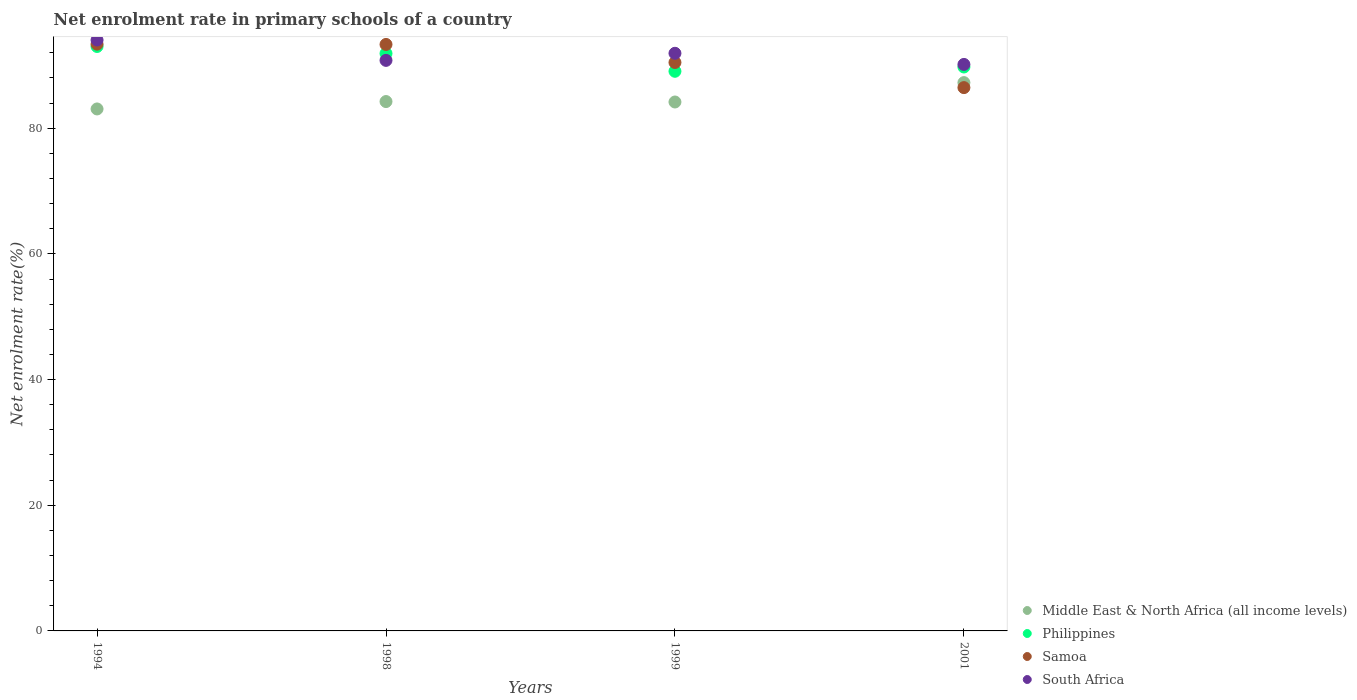How many different coloured dotlines are there?
Ensure brevity in your answer.  4. What is the net enrolment rate in primary schools in South Africa in 1994?
Make the answer very short. 94.03. Across all years, what is the maximum net enrolment rate in primary schools in South Africa?
Provide a short and direct response. 94.03. Across all years, what is the minimum net enrolment rate in primary schools in South Africa?
Make the answer very short. 90.15. In which year was the net enrolment rate in primary schools in Philippines maximum?
Ensure brevity in your answer.  1994. In which year was the net enrolment rate in primary schools in Middle East & North Africa (all income levels) minimum?
Ensure brevity in your answer.  1994. What is the total net enrolment rate in primary schools in Samoa in the graph?
Provide a short and direct response. 363.62. What is the difference between the net enrolment rate in primary schools in Middle East & North Africa (all income levels) in 1994 and that in 1998?
Provide a short and direct response. -1.18. What is the difference between the net enrolment rate in primary schools in Philippines in 1998 and the net enrolment rate in primary schools in Middle East & North Africa (all income levels) in 1994?
Ensure brevity in your answer.  8.83. What is the average net enrolment rate in primary schools in Philippines per year?
Offer a terse response. 90.92. In the year 1999, what is the difference between the net enrolment rate in primary schools in Philippines and net enrolment rate in primary schools in Samoa?
Ensure brevity in your answer.  -1.4. What is the ratio of the net enrolment rate in primary schools in Philippines in 1999 to that in 2001?
Ensure brevity in your answer.  0.99. Is the difference between the net enrolment rate in primary schools in Philippines in 1999 and 2001 greater than the difference between the net enrolment rate in primary schools in Samoa in 1999 and 2001?
Make the answer very short. No. What is the difference between the highest and the second highest net enrolment rate in primary schools in South Africa?
Keep it short and to the point. 2.11. What is the difference between the highest and the lowest net enrolment rate in primary schools in Samoa?
Your answer should be compact. 6.91. In how many years, is the net enrolment rate in primary schools in South Africa greater than the average net enrolment rate in primary schools in South Africa taken over all years?
Give a very brief answer. 2. Is the sum of the net enrolment rate in primary schools in Philippines in 1998 and 2001 greater than the maximum net enrolment rate in primary schools in Middle East & North Africa (all income levels) across all years?
Provide a short and direct response. Yes. Is it the case that in every year, the sum of the net enrolment rate in primary schools in South Africa and net enrolment rate in primary schools in Samoa  is greater than the net enrolment rate in primary schools in Philippines?
Your answer should be compact. Yes. Is the net enrolment rate in primary schools in Philippines strictly greater than the net enrolment rate in primary schools in South Africa over the years?
Your response must be concise. No. Is the net enrolment rate in primary schools in Philippines strictly less than the net enrolment rate in primary schools in Samoa over the years?
Offer a very short reply. No. How many dotlines are there?
Your response must be concise. 4. How many years are there in the graph?
Offer a very short reply. 4. What is the difference between two consecutive major ticks on the Y-axis?
Your answer should be very brief. 20. Does the graph contain grids?
Offer a very short reply. No. How many legend labels are there?
Make the answer very short. 4. How are the legend labels stacked?
Provide a succinct answer. Vertical. What is the title of the graph?
Provide a succinct answer. Net enrolment rate in primary schools of a country. What is the label or title of the X-axis?
Give a very brief answer. Years. What is the label or title of the Y-axis?
Provide a succinct answer. Net enrolment rate(%). What is the Net enrolment rate(%) of Middle East & North Africa (all income levels) in 1994?
Your answer should be compact. 83.06. What is the Net enrolment rate(%) in Philippines in 1994?
Provide a succinct answer. 93.01. What is the Net enrolment rate(%) of Samoa in 1994?
Ensure brevity in your answer.  93.37. What is the Net enrolment rate(%) in South Africa in 1994?
Offer a very short reply. 94.03. What is the Net enrolment rate(%) of Middle East & North Africa (all income levels) in 1998?
Make the answer very short. 84.24. What is the Net enrolment rate(%) in Philippines in 1998?
Your answer should be very brief. 91.89. What is the Net enrolment rate(%) in Samoa in 1998?
Keep it short and to the point. 93.33. What is the Net enrolment rate(%) in South Africa in 1998?
Ensure brevity in your answer.  90.79. What is the Net enrolment rate(%) of Middle East & North Africa (all income levels) in 1999?
Ensure brevity in your answer.  84.17. What is the Net enrolment rate(%) of Philippines in 1999?
Ensure brevity in your answer.  89.06. What is the Net enrolment rate(%) of Samoa in 1999?
Provide a succinct answer. 90.46. What is the Net enrolment rate(%) in South Africa in 1999?
Keep it short and to the point. 91.92. What is the Net enrolment rate(%) in Middle East & North Africa (all income levels) in 2001?
Keep it short and to the point. 87.25. What is the Net enrolment rate(%) in Philippines in 2001?
Offer a terse response. 89.74. What is the Net enrolment rate(%) in Samoa in 2001?
Give a very brief answer. 86.46. What is the Net enrolment rate(%) of South Africa in 2001?
Your response must be concise. 90.15. Across all years, what is the maximum Net enrolment rate(%) in Middle East & North Africa (all income levels)?
Your answer should be very brief. 87.25. Across all years, what is the maximum Net enrolment rate(%) in Philippines?
Keep it short and to the point. 93.01. Across all years, what is the maximum Net enrolment rate(%) of Samoa?
Your answer should be very brief. 93.37. Across all years, what is the maximum Net enrolment rate(%) in South Africa?
Ensure brevity in your answer.  94.03. Across all years, what is the minimum Net enrolment rate(%) in Middle East & North Africa (all income levels)?
Keep it short and to the point. 83.06. Across all years, what is the minimum Net enrolment rate(%) in Philippines?
Keep it short and to the point. 89.06. Across all years, what is the minimum Net enrolment rate(%) of Samoa?
Give a very brief answer. 86.46. Across all years, what is the minimum Net enrolment rate(%) of South Africa?
Give a very brief answer. 90.15. What is the total Net enrolment rate(%) of Middle East & North Africa (all income levels) in the graph?
Your response must be concise. 338.73. What is the total Net enrolment rate(%) of Philippines in the graph?
Your answer should be very brief. 363.7. What is the total Net enrolment rate(%) in Samoa in the graph?
Your response must be concise. 363.62. What is the total Net enrolment rate(%) of South Africa in the graph?
Offer a very short reply. 366.9. What is the difference between the Net enrolment rate(%) in Middle East & North Africa (all income levels) in 1994 and that in 1998?
Keep it short and to the point. -1.18. What is the difference between the Net enrolment rate(%) of Philippines in 1994 and that in 1998?
Provide a succinct answer. 1.12. What is the difference between the Net enrolment rate(%) in Samoa in 1994 and that in 1998?
Your answer should be very brief. 0.04. What is the difference between the Net enrolment rate(%) of South Africa in 1994 and that in 1998?
Make the answer very short. 3.24. What is the difference between the Net enrolment rate(%) of Middle East & North Africa (all income levels) in 1994 and that in 1999?
Ensure brevity in your answer.  -1.11. What is the difference between the Net enrolment rate(%) of Philippines in 1994 and that in 1999?
Keep it short and to the point. 3.95. What is the difference between the Net enrolment rate(%) in Samoa in 1994 and that in 1999?
Give a very brief answer. 2.92. What is the difference between the Net enrolment rate(%) of South Africa in 1994 and that in 1999?
Your answer should be very brief. 2.11. What is the difference between the Net enrolment rate(%) in Middle East & North Africa (all income levels) in 1994 and that in 2001?
Offer a very short reply. -4.19. What is the difference between the Net enrolment rate(%) of Philippines in 1994 and that in 2001?
Offer a very short reply. 3.27. What is the difference between the Net enrolment rate(%) in Samoa in 1994 and that in 2001?
Make the answer very short. 6.91. What is the difference between the Net enrolment rate(%) of South Africa in 1994 and that in 2001?
Give a very brief answer. 3.88. What is the difference between the Net enrolment rate(%) in Middle East & North Africa (all income levels) in 1998 and that in 1999?
Keep it short and to the point. 0.07. What is the difference between the Net enrolment rate(%) of Philippines in 1998 and that in 1999?
Offer a very short reply. 2.83. What is the difference between the Net enrolment rate(%) of Samoa in 1998 and that in 1999?
Provide a succinct answer. 2.87. What is the difference between the Net enrolment rate(%) in South Africa in 1998 and that in 1999?
Offer a very short reply. -1.13. What is the difference between the Net enrolment rate(%) in Middle East & North Africa (all income levels) in 1998 and that in 2001?
Your answer should be compact. -3.01. What is the difference between the Net enrolment rate(%) of Philippines in 1998 and that in 2001?
Your answer should be compact. 2.15. What is the difference between the Net enrolment rate(%) in Samoa in 1998 and that in 2001?
Your response must be concise. 6.87. What is the difference between the Net enrolment rate(%) of South Africa in 1998 and that in 2001?
Keep it short and to the point. 0.64. What is the difference between the Net enrolment rate(%) in Middle East & North Africa (all income levels) in 1999 and that in 2001?
Ensure brevity in your answer.  -3.08. What is the difference between the Net enrolment rate(%) in Philippines in 1999 and that in 2001?
Provide a short and direct response. -0.68. What is the difference between the Net enrolment rate(%) of Samoa in 1999 and that in 2001?
Provide a succinct answer. 4. What is the difference between the Net enrolment rate(%) of South Africa in 1999 and that in 2001?
Provide a succinct answer. 1.77. What is the difference between the Net enrolment rate(%) of Middle East & North Africa (all income levels) in 1994 and the Net enrolment rate(%) of Philippines in 1998?
Offer a terse response. -8.83. What is the difference between the Net enrolment rate(%) in Middle East & North Africa (all income levels) in 1994 and the Net enrolment rate(%) in Samoa in 1998?
Your response must be concise. -10.27. What is the difference between the Net enrolment rate(%) in Middle East & North Africa (all income levels) in 1994 and the Net enrolment rate(%) in South Africa in 1998?
Keep it short and to the point. -7.73. What is the difference between the Net enrolment rate(%) of Philippines in 1994 and the Net enrolment rate(%) of Samoa in 1998?
Your answer should be compact. -0.32. What is the difference between the Net enrolment rate(%) of Philippines in 1994 and the Net enrolment rate(%) of South Africa in 1998?
Your answer should be very brief. 2.21. What is the difference between the Net enrolment rate(%) of Samoa in 1994 and the Net enrolment rate(%) of South Africa in 1998?
Your answer should be compact. 2.58. What is the difference between the Net enrolment rate(%) in Middle East & North Africa (all income levels) in 1994 and the Net enrolment rate(%) in Philippines in 1999?
Give a very brief answer. -5.99. What is the difference between the Net enrolment rate(%) of Middle East & North Africa (all income levels) in 1994 and the Net enrolment rate(%) of Samoa in 1999?
Give a very brief answer. -7.39. What is the difference between the Net enrolment rate(%) of Middle East & North Africa (all income levels) in 1994 and the Net enrolment rate(%) of South Africa in 1999?
Offer a very short reply. -8.86. What is the difference between the Net enrolment rate(%) of Philippines in 1994 and the Net enrolment rate(%) of Samoa in 1999?
Your response must be concise. 2.55. What is the difference between the Net enrolment rate(%) of Philippines in 1994 and the Net enrolment rate(%) of South Africa in 1999?
Provide a succinct answer. 1.09. What is the difference between the Net enrolment rate(%) of Samoa in 1994 and the Net enrolment rate(%) of South Africa in 1999?
Your response must be concise. 1.45. What is the difference between the Net enrolment rate(%) of Middle East & North Africa (all income levels) in 1994 and the Net enrolment rate(%) of Philippines in 2001?
Offer a very short reply. -6.68. What is the difference between the Net enrolment rate(%) in Middle East & North Africa (all income levels) in 1994 and the Net enrolment rate(%) in Samoa in 2001?
Offer a very short reply. -3.4. What is the difference between the Net enrolment rate(%) in Middle East & North Africa (all income levels) in 1994 and the Net enrolment rate(%) in South Africa in 2001?
Ensure brevity in your answer.  -7.09. What is the difference between the Net enrolment rate(%) in Philippines in 1994 and the Net enrolment rate(%) in Samoa in 2001?
Ensure brevity in your answer.  6.55. What is the difference between the Net enrolment rate(%) in Philippines in 1994 and the Net enrolment rate(%) in South Africa in 2001?
Your answer should be very brief. 2.86. What is the difference between the Net enrolment rate(%) in Samoa in 1994 and the Net enrolment rate(%) in South Africa in 2001?
Offer a terse response. 3.22. What is the difference between the Net enrolment rate(%) of Middle East & North Africa (all income levels) in 1998 and the Net enrolment rate(%) of Philippines in 1999?
Ensure brevity in your answer.  -4.82. What is the difference between the Net enrolment rate(%) in Middle East & North Africa (all income levels) in 1998 and the Net enrolment rate(%) in Samoa in 1999?
Ensure brevity in your answer.  -6.22. What is the difference between the Net enrolment rate(%) in Middle East & North Africa (all income levels) in 1998 and the Net enrolment rate(%) in South Africa in 1999?
Give a very brief answer. -7.68. What is the difference between the Net enrolment rate(%) of Philippines in 1998 and the Net enrolment rate(%) of Samoa in 1999?
Provide a succinct answer. 1.43. What is the difference between the Net enrolment rate(%) of Philippines in 1998 and the Net enrolment rate(%) of South Africa in 1999?
Offer a very short reply. -0.03. What is the difference between the Net enrolment rate(%) in Samoa in 1998 and the Net enrolment rate(%) in South Africa in 1999?
Keep it short and to the point. 1.41. What is the difference between the Net enrolment rate(%) in Middle East & North Africa (all income levels) in 1998 and the Net enrolment rate(%) in Samoa in 2001?
Make the answer very short. -2.22. What is the difference between the Net enrolment rate(%) in Middle East & North Africa (all income levels) in 1998 and the Net enrolment rate(%) in South Africa in 2001?
Offer a terse response. -5.91. What is the difference between the Net enrolment rate(%) of Philippines in 1998 and the Net enrolment rate(%) of Samoa in 2001?
Keep it short and to the point. 5.43. What is the difference between the Net enrolment rate(%) of Philippines in 1998 and the Net enrolment rate(%) of South Africa in 2001?
Your answer should be very brief. 1.74. What is the difference between the Net enrolment rate(%) of Samoa in 1998 and the Net enrolment rate(%) of South Africa in 2001?
Give a very brief answer. 3.18. What is the difference between the Net enrolment rate(%) of Middle East & North Africa (all income levels) in 1999 and the Net enrolment rate(%) of Philippines in 2001?
Keep it short and to the point. -5.57. What is the difference between the Net enrolment rate(%) of Middle East & North Africa (all income levels) in 1999 and the Net enrolment rate(%) of Samoa in 2001?
Provide a short and direct response. -2.29. What is the difference between the Net enrolment rate(%) of Middle East & North Africa (all income levels) in 1999 and the Net enrolment rate(%) of South Africa in 2001?
Your response must be concise. -5.98. What is the difference between the Net enrolment rate(%) of Philippines in 1999 and the Net enrolment rate(%) of Samoa in 2001?
Give a very brief answer. 2.6. What is the difference between the Net enrolment rate(%) of Philippines in 1999 and the Net enrolment rate(%) of South Africa in 2001?
Your answer should be very brief. -1.09. What is the difference between the Net enrolment rate(%) of Samoa in 1999 and the Net enrolment rate(%) of South Africa in 2001?
Provide a succinct answer. 0.31. What is the average Net enrolment rate(%) in Middle East & North Africa (all income levels) per year?
Offer a terse response. 84.68. What is the average Net enrolment rate(%) of Philippines per year?
Keep it short and to the point. 90.92. What is the average Net enrolment rate(%) in Samoa per year?
Provide a short and direct response. 90.9. What is the average Net enrolment rate(%) of South Africa per year?
Your response must be concise. 91.72. In the year 1994, what is the difference between the Net enrolment rate(%) in Middle East & North Africa (all income levels) and Net enrolment rate(%) in Philippines?
Your response must be concise. -9.94. In the year 1994, what is the difference between the Net enrolment rate(%) in Middle East & North Africa (all income levels) and Net enrolment rate(%) in Samoa?
Ensure brevity in your answer.  -10.31. In the year 1994, what is the difference between the Net enrolment rate(%) of Middle East & North Africa (all income levels) and Net enrolment rate(%) of South Africa?
Ensure brevity in your answer.  -10.97. In the year 1994, what is the difference between the Net enrolment rate(%) in Philippines and Net enrolment rate(%) in Samoa?
Your answer should be very brief. -0.37. In the year 1994, what is the difference between the Net enrolment rate(%) in Philippines and Net enrolment rate(%) in South Africa?
Offer a very short reply. -1.03. In the year 1994, what is the difference between the Net enrolment rate(%) of Samoa and Net enrolment rate(%) of South Africa?
Offer a terse response. -0.66. In the year 1998, what is the difference between the Net enrolment rate(%) of Middle East & North Africa (all income levels) and Net enrolment rate(%) of Philippines?
Make the answer very short. -7.65. In the year 1998, what is the difference between the Net enrolment rate(%) of Middle East & North Africa (all income levels) and Net enrolment rate(%) of Samoa?
Provide a succinct answer. -9.09. In the year 1998, what is the difference between the Net enrolment rate(%) in Middle East & North Africa (all income levels) and Net enrolment rate(%) in South Africa?
Offer a terse response. -6.55. In the year 1998, what is the difference between the Net enrolment rate(%) of Philippines and Net enrolment rate(%) of Samoa?
Your response must be concise. -1.44. In the year 1998, what is the difference between the Net enrolment rate(%) of Philippines and Net enrolment rate(%) of South Africa?
Your response must be concise. 1.1. In the year 1998, what is the difference between the Net enrolment rate(%) in Samoa and Net enrolment rate(%) in South Africa?
Make the answer very short. 2.54. In the year 1999, what is the difference between the Net enrolment rate(%) of Middle East & North Africa (all income levels) and Net enrolment rate(%) of Philippines?
Ensure brevity in your answer.  -4.89. In the year 1999, what is the difference between the Net enrolment rate(%) of Middle East & North Africa (all income levels) and Net enrolment rate(%) of Samoa?
Keep it short and to the point. -6.29. In the year 1999, what is the difference between the Net enrolment rate(%) in Middle East & North Africa (all income levels) and Net enrolment rate(%) in South Africa?
Your answer should be compact. -7.75. In the year 1999, what is the difference between the Net enrolment rate(%) of Philippines and Net enrolment rate(%) of Samoa?
Provide a short and direct response. -1.4. In the year 1999, what is the difference between the Net enrolment rate(%) in Philippines and Net enrolment rate(%) in South Africa?
Keep it short and to the point. -2.86. In the year 1999, what is the difference between the Net enrolment rate(%) in Samoa and Net enrolment rate(%) in South Africa?
Offer a very short reply. -1.46. In the year 2001, what is the difference between the Net enrolment rate(%) in Middle East & North Africa (all income levels) and Net enrolment rate(%) in Philippines?
Keep it short and to the point. -2.49. In the year 2001, what is the difference between the Net enrolment rate(%) of Middle East & North Africa (all income levels) and Net enrolment rate(%) of Samoa?
Offer a terse response. 0.79. In the year 2001, what is the difference between the Net enrolment rate(%) in Middle East & North Africa (all income levels) and Net enrolment rate(%) in South Africa?
Your answer should be compact. -2.9. In the year 2001, what is the difference between the Net enrolment rate(%) of Philippines and Net enrolment rate(%) of Samoa?
Offer a terse response. 3.28. In the year 2001, what is the difference between the Net enrolment rate(%) in Philippines and Net enrolment rate(%) in South Africa?
Your response must be concise. -0.41. In the year 2001, what is the difference between the Net enrolment rate(%) in Samoa and Net enrolment rate(%) in South Africa?
Your response must be concise. -3.69. What is the ratio of the Net enrolment rate(%) of Middle East & North Africa (all income levels) in 1994 to that in 1998?
Provide a succinct answer. 0.99. What is the ratio of the Net enrolment rate(%) in Philippines in 1994 to that in 1998?
Keep it short and to the point. 1.01. What is the ratio of the Net enrolment rate(%) of Samoa in 1994 to that in 1998?
Your response must be concise. 1. What is the ratio of the Net enrolment rate(%) in South Africa in 1994 to that in 1998?
Your answer should be very brief. 1.04. What is the ratio of the Net enrolment rate(%) in Philippines in 1994 to that in 1999?
Offer a terse response. 1.04. What is the ratio of the Net enrolment rate(%) in Samoa in 1994 to that in 1999?
Your answer should be very brief. 1.03. What is the ratio of the Net enrolment rate(%) of Philippines in 1994 to that in 2001?
Give a very brief answer. 1.04. What is the ratio of the Net enrolment rate(%) in Samoa in 1994 to that in 2001?
Provide a succinct answer. 1.08. What is the ratio of the Net enrolment rate(%) of South Africa in 1994 to that in 2001?
Offer a very short reply. 1.04. What is the ratio of the Net enrolment rate(%) in Philippines in 1998 to that in 1999?
Keep it short and to the point. 1.03. What is the ratio of the Net enrolment rate(%) in Samoa in 1998 to that in 1999?
Provide a short and direct response. 1.03. What is the ratio of the Net enrolment rate(%) in South Africa in 1998 to that in 1999?
Ensure brevity in your answer.  0.99. What is the ratio of the Net enrolment rate(%) of Middle East & North Africa (all income levels) in 1998 to that in 2001?
Your answer should be compact. 0.97. What is the ratio of the Net enrolment rate(%) of Samoa in 1998 to that in 2001?
Your answer should be compact. 1.08. What is the ratio of the Net enrolment rate(%) of Middle East & North Africa (all income levels) in 1999 to that in 2001?
Keep it short and to the point. 0.96. What is the ratio of the Net enrolment rate(%) in Philippines in 1999 to that in 2001?
Offer a very short reply. 0.99. What is the ratio of the Net enrolment rate(%) in Samoa in 1999 to that in 2001?
Offer a terse response. 1.05. What is the ratio of the Net enrolment rate(%) in South Africa in 1999 to that in 2001?
Your response must be concise. 1.02. What is the difference between the highest and the second highest Net enrolment rate(%) of Middle East & North Africa (all income levels)?
Provide a short and direct response. 3.01. What is the difference between the highest and the second highest Net enrolment rate(%) in Philippines?
Keep it short and to the point. 1.12. What is the difference between the highest and the second highest Net enrolment rate(%) in Samoa?
Give a very brief answer. 0.04. What is the difference between the highest and the second highest Net enrolment rate(%) in South Africa?
Provide a short and direct response. 2.11. What is the difference between the highest and the lowest Net enrolment rate(%) in Middle East & North Africa (all income levels)?
Give a very brief answer. 4.19. What is the difference between the highest and the lowest Net enrolment rate(%) of Philippines?
Ensure brevity in your answer.  3.95. What is the difference between the highest and the lowest Net enrolment rate(%) in Samoa?
Make the answer very short. 6.91. What is the difference between the highest and the lowest Net enrolment rate(%) of South Africa?
Offer a terse response. 3.88. 